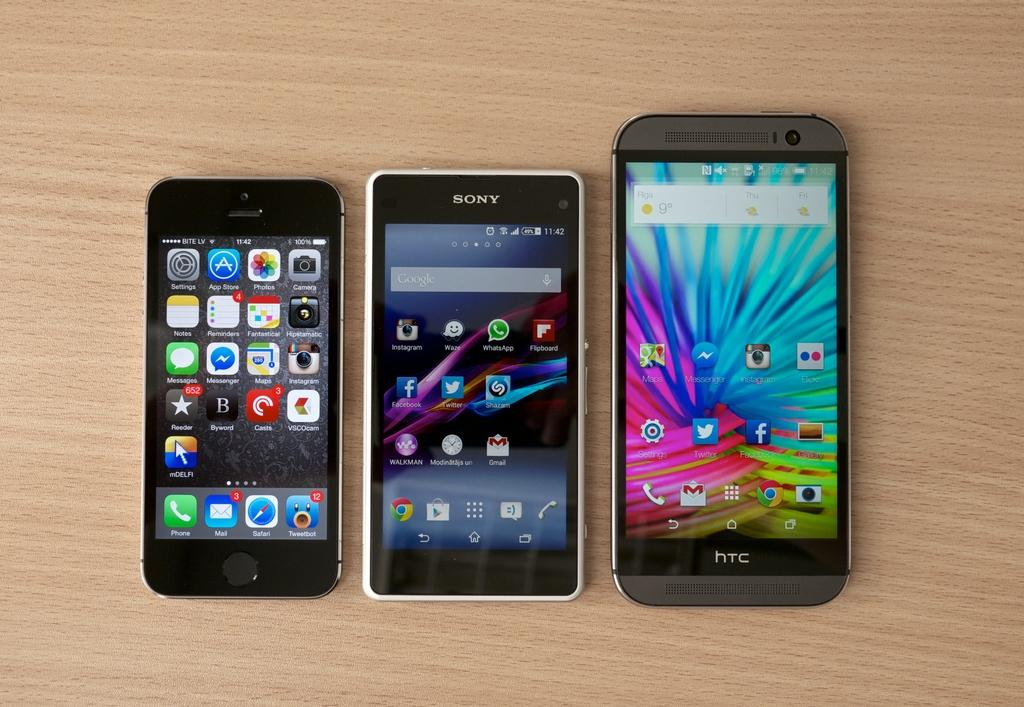Provide a one-sentence caption for the provided image. Three cell phones, one is an iPhone, the middle is a Sony brand, and the right one is a HTC. 